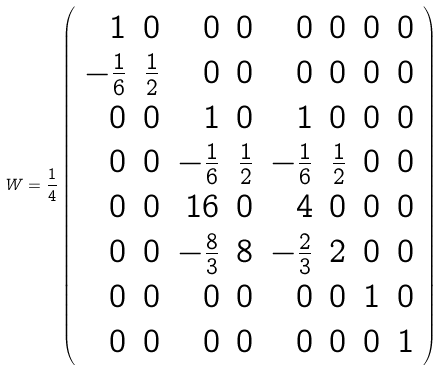<formula> <loc_0><loc_0><loc_500><loc_500>W = \frac { 1 } { 4 } \left ( \begin{array} { r r r r r r r r } 1 & 0 & 0 & 0 & 0 & 0 & 0 & 0 \\ - \frac { 1 } { 6 } & \frac { 1 } { 2 } & 0 & 0 & 0 & 0 & 0 & 0 \\ 0 & 0 & 1 & 0 & 1 & 0 & 0 & 0 \\ 0 & 0 & - \frac { 1 } { 6 } & \frac { 1 } { 2 } & - \frac { 1 } { 6 } & \frac { 1 } { 2 } & 0 & 0 \\ 0 & 0 & 1 6 & 0 & 4 & 0 & 0 & 0 \\ 0 & 0 & - \frac { 8 } { 3 } & 8 & - \frac { 2 } { 3 } & 2 & 0 & 0 \\ 0 & 0 & 0 & 0 & 0 & 0 & 1 & 0 \\ 0 & 0 & 0 & 0 & 0 & 0 & 0 & 1 \end{array} \right )</formula> 